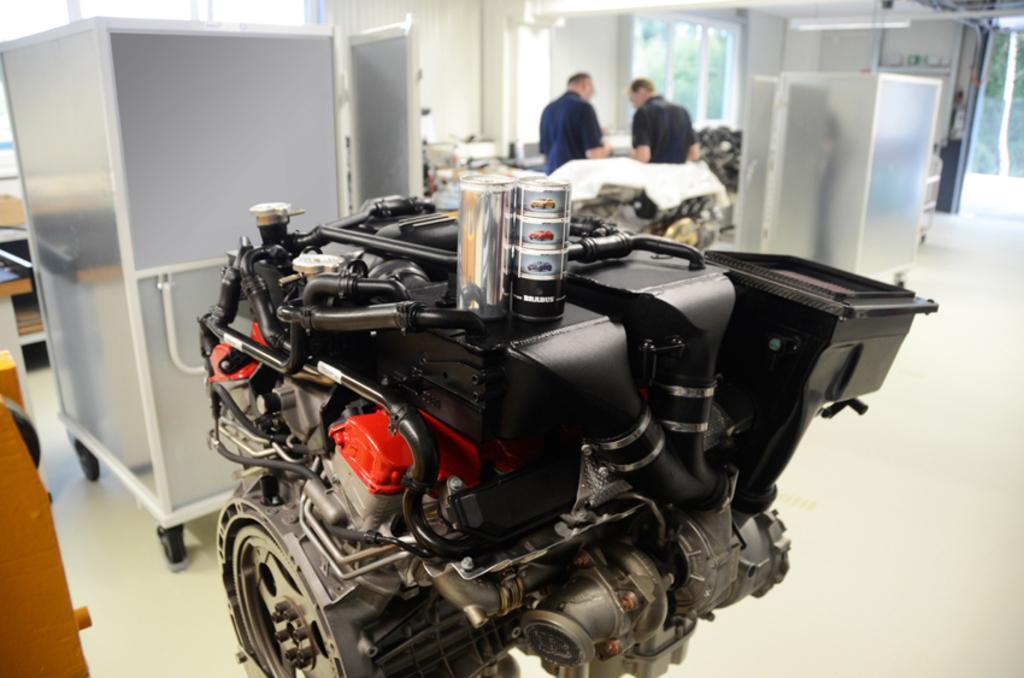In one or two sentences, can you explain what this image depicts? In this image we can see two persons standing, there are some electrical machines and in the background there are some trees. 